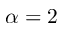<formula> <loc_0><loc_0><loc_500><loc_500>\alpha = 2</formula> 